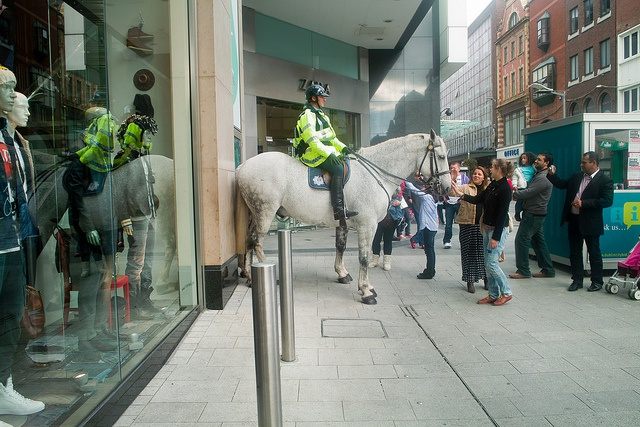Describe the objects in this image and their specific colors. I can see horse in gray, darkgray, and lightgray tones, horse in gray, black, and darkgray tones, people in gray, black, teal, and darkgray tones, people in gray, black, ivory, and teal tones, and people in gray and black tones in this image. 